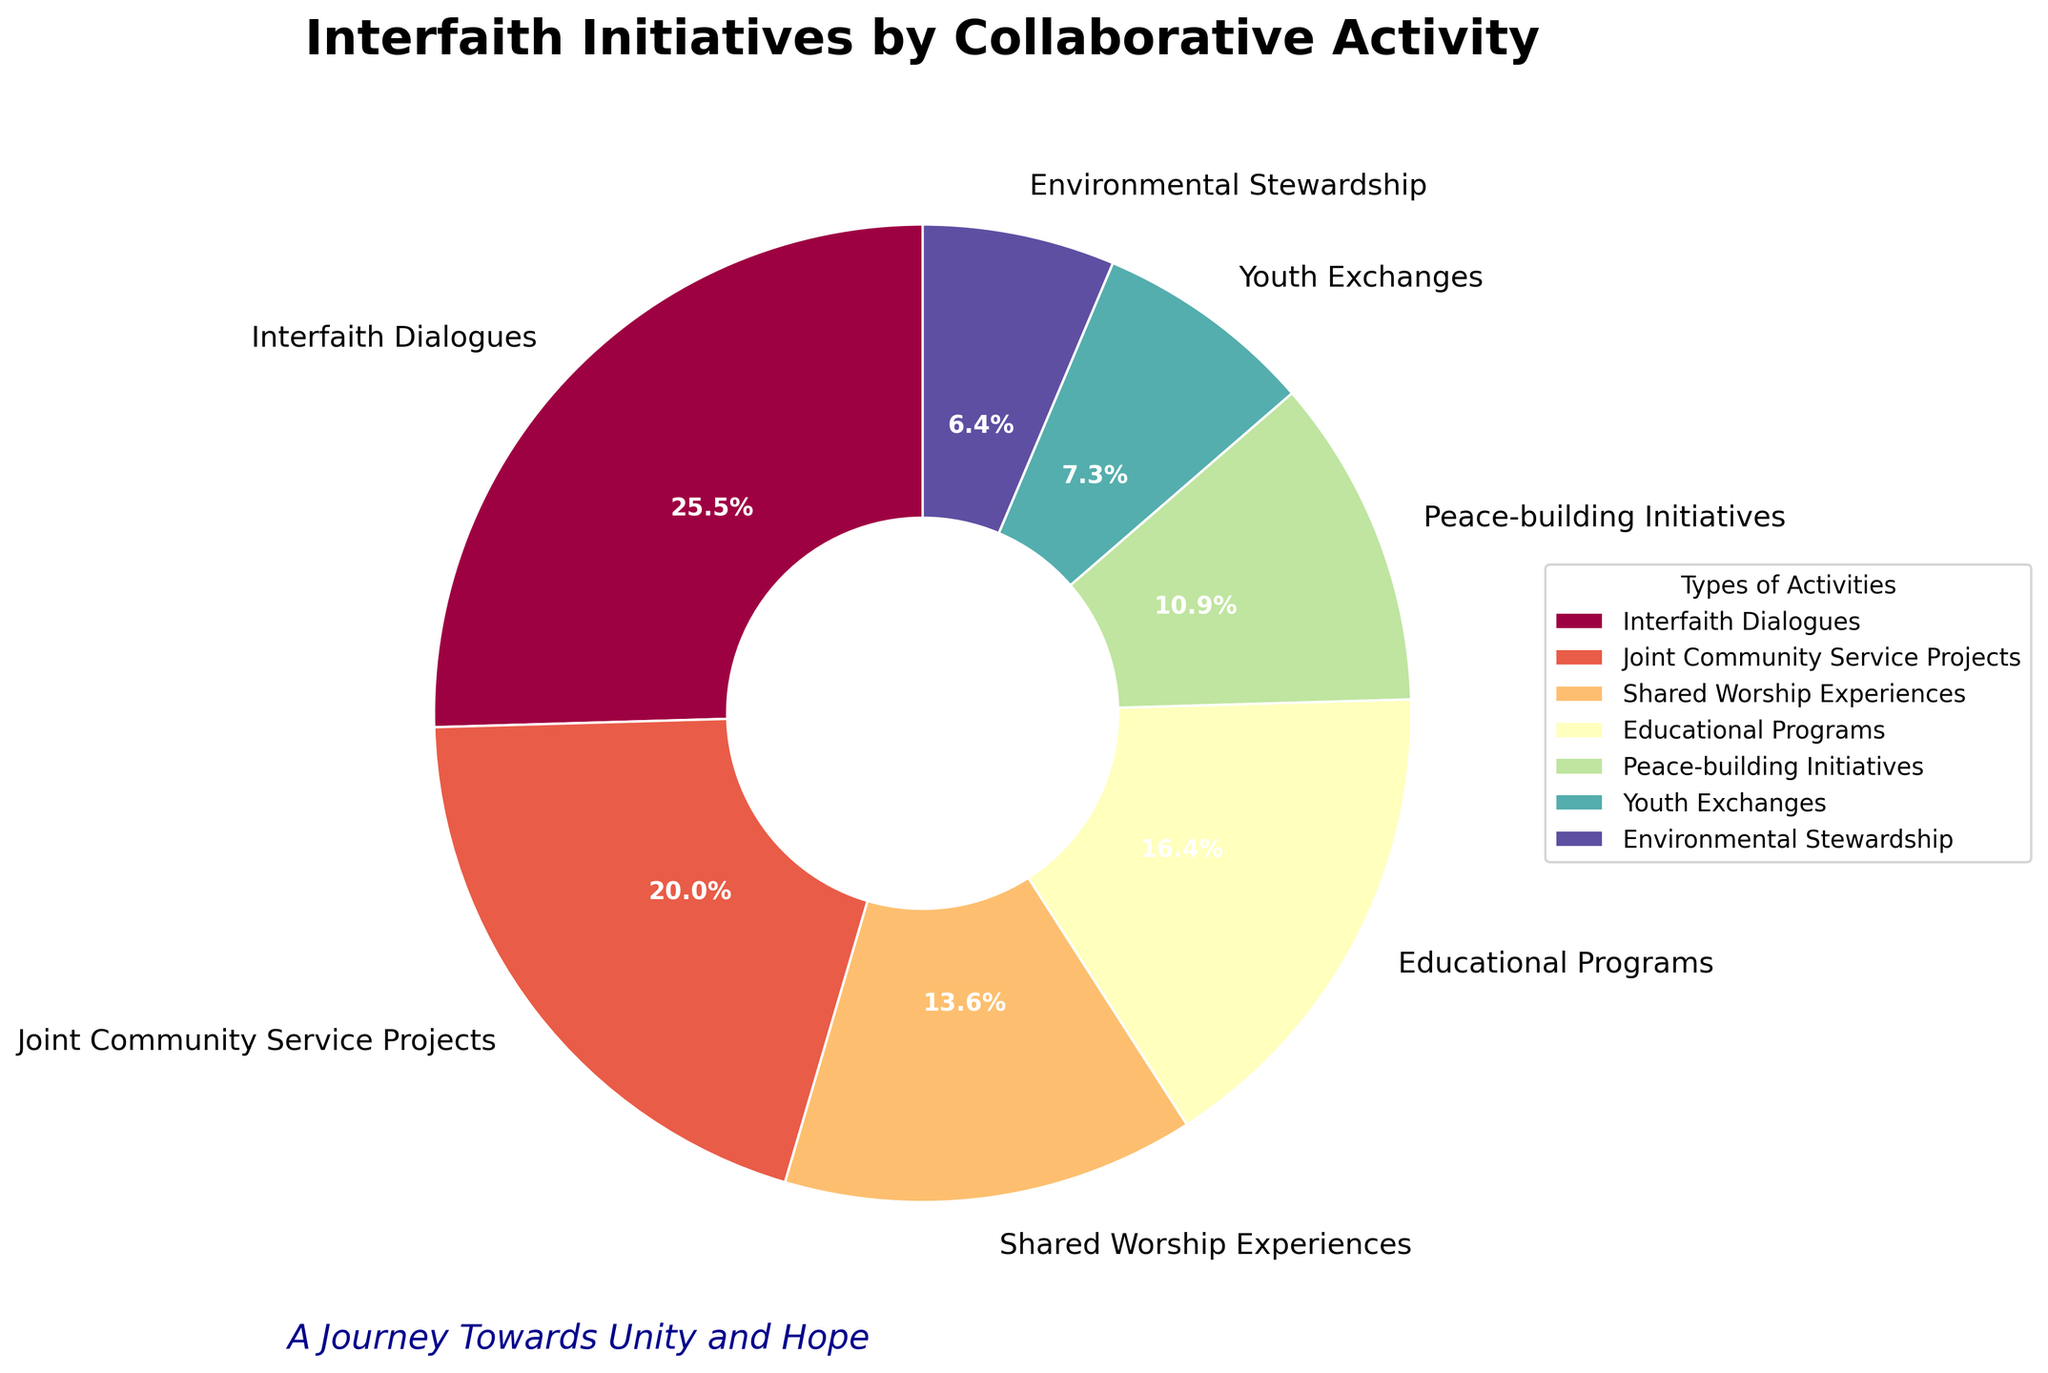Which type of collaborative activity has the highest percentage? The pie chart displays various types of collaborative activities with their respective percentages. By examining these percentages, it's clear that "Interfaith Dialogues" has the highest percentage at 28%.
Answer: Interfaith Dialogues Which activity type shares an equal percentage with Educational Programs and Environmental Stewardship combined? According to the pie chart, Educational Programs have 18% and Environmental Stewardship has 7%. Adding these together gives 25%. Joint Community Service Projects is at 22%, and no type matches 25%. Therefore, no type shares the combined percentage of these two activities.
Answer: None How does the percentage of Peace-building Initiatives compare to Youth Exchanges? The percentage of Peace-building Initiatives is 12%, whereas Youth Exchanges is at 8%. By comparing these values, we see that Peace-building Initiatives have a higher percentage than Youth Exchanges.
Answer: Peace-building Initiatives have a higher percentage What is the combined percentage of all activities that have more than 20%? The activities with more than 20% are "Interfaith Dialogues" (28%) and "Joint Community Service Projects" (22%). Adding these together, 28% + 22% = 50%.
Answer: 50% Which activity type has the smallest percentage share? According to the pie chart, "Environmental Stewardship" has the smallest percentage share at 7%.
Answer: Environmental Stewardship Compare the sum of the percentages of Shared Worship Experiences and Youth Exchanges to Interfaith Dialogues. Which is greater? Shared Worship Experiences are 15% and Youth Exchanges are 8%. Their sum is 15% + 8% = 23%. Interfaith Dialogues have a percentage of 28%, which is greater.
Answer: Interfaith Dialogues is greater What percentage of initiatives are related to Educational Programs? The pie chart indicates that 18% of the initiatives are related to Educational Programs.
Answer: 18% How much more is the percentage of Interfaith Dialogues compared to Peace-building Initiatives? Interfaith Dialogues are at 28% and Peace-building Initiatives are at 12%. The difference between them is 28% - 12% = 16%.
Answer: 16% By how much does the percentage share of Joint Community Service Projects exceed that of Shared Worship Experiences? Joint Community Service Projects have a 22% share, while Shared Worship Experiences have 15%. The difference is 22% - 15% = 7%.
Answer: 7% 